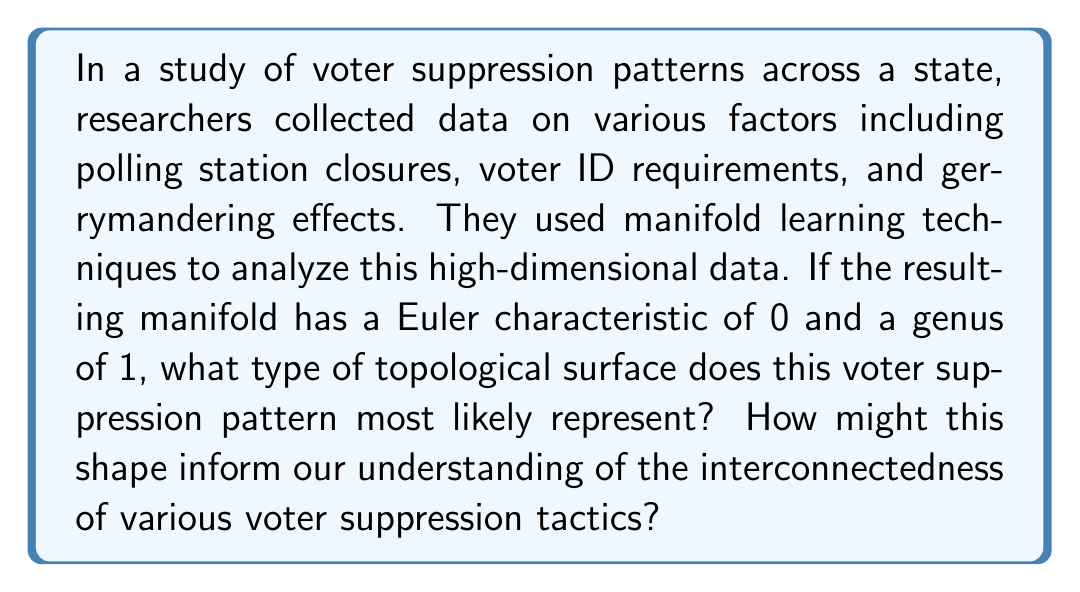Help me with this question. To answer this question, we need to understand the topological properties of manifolds and their implications in the context of voter suppression patterns:

1) The Euler characteristic ($\chi$) is given by the formula:

   $$\chi = V - E + F$$

   where $V$ is the number of vertices, $E$ is the number of edges, and $F$ is the number of faces.

2) The genus ($g$) of a surface is the number of handles or holes it has. It's related to the Euler characteristic by the formula:

   $$\chi = 2 - 2g$$

3) Given information:
   - Euler characteristic ($\chi$) = 0
   - Genus ($g$) = 1

4) Let's substitute these values into the formula:

   $$0 = 2 - 2(1)$$
   $$0 = 2 - 2 = 0$$

5) This equality holds true, confirming our given information.

6) A surface with Euler characteristic 0 and genus 1 is topologically equivalent to a torus.

7) In the context of voter suppression:
   - The toroidal shape suggests a cyclic, interconnected nature of various suppression tactics.
   - It implies that different suppression methods (represented by points on the surface) are connected in complex ways, potentially reinforcing each other.
   - The hole in the torus might represent a "blind spot" or gap in the suppression network, possibly indicating areas where interventions could be most effective.

8) This topological representation can inform civil rights activists about the systemic nature of voter suppression, highlighting the need for comprehensive rather than piecemeal solutions.
Answer: The voter suppression pattern most likely represents a torus. This shape suggests a cyclical and interconnected nature of suppression tactics, implying that different methods reinforce each other in a complex network. The toroidal structure also indicates potential "blind spots" in the suppression system, which could be targeted for effective intervention by civil rights activists. 